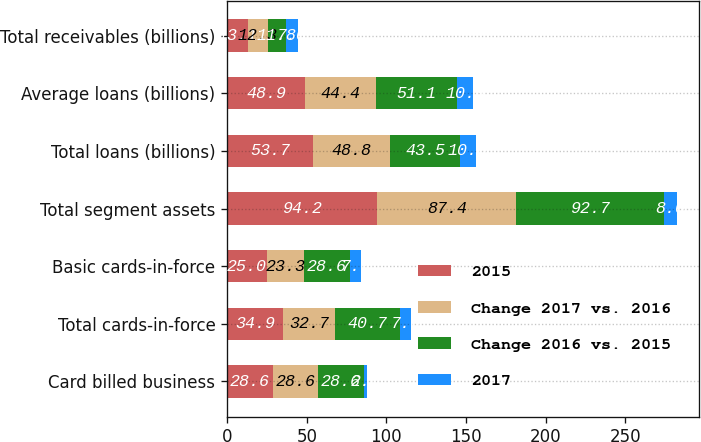Convert chart to OTSL. <chart><loc_0><loc_0><loc_500><loc_500><stacked_bar_chart><ecel><fcel>Card billed business<fcel>Total cards-in-force<fcel>Basic cards-in-force<fcel>Total segment assets<fcel>Total loans (billions)<fcel>Average loans (billions)<fcel>Total receivables (billions)<nl><fcel>2015<fcel>28.6<fcel>34.9<fcel>25<fcel>94.2<fcel>53.7<fcel>48.9<fcel>13.1<nl><fcel>Change 2017 vs. 2016<fcel>28.6<fcel>32.7<fcel>23.3<fcel>87.4<fcel>48.8<fcel>44.4<fcel>12.3<nl><fcel>Change 2016 vs. 2015<fcel>28.6<fcel>40.7<fcel>28.6<fcel>92.7<fcel>43.5<fcel>51.1<fcel>11.8<nl><fcel>2017<fcel>2<fcel>7<fcel>7<fcel>8<fcel>10<fcel>10<fcel>7<nl></chart> 